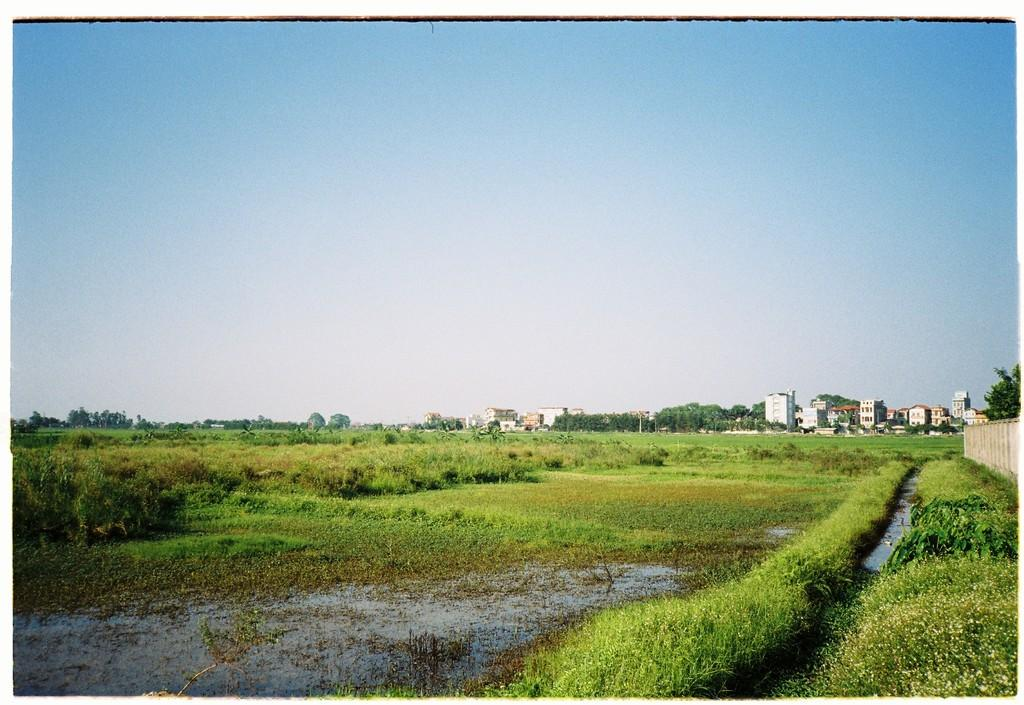What type of vegetation is present in the image? There is grass in the image. What else can be seen in the image besides grass? There is water, plants on the left side, trees in the background, buildings in the background, and the sky visible in the background. Can you describe the plants on the left side of the image? The plants on the left side of the image are not specified, but they are present alongside the grass. What is the natural environment like in the image? The natural environment includes grass, water, and trees. What does the stomach of the person in the image feel like? There is no person present in the image, so it is not possible to determine how their stomach feels. What need does the image fulfill for the viewer? The image does not fulfill any specific need for the viewer, as it is a static representation of a natural environment. 